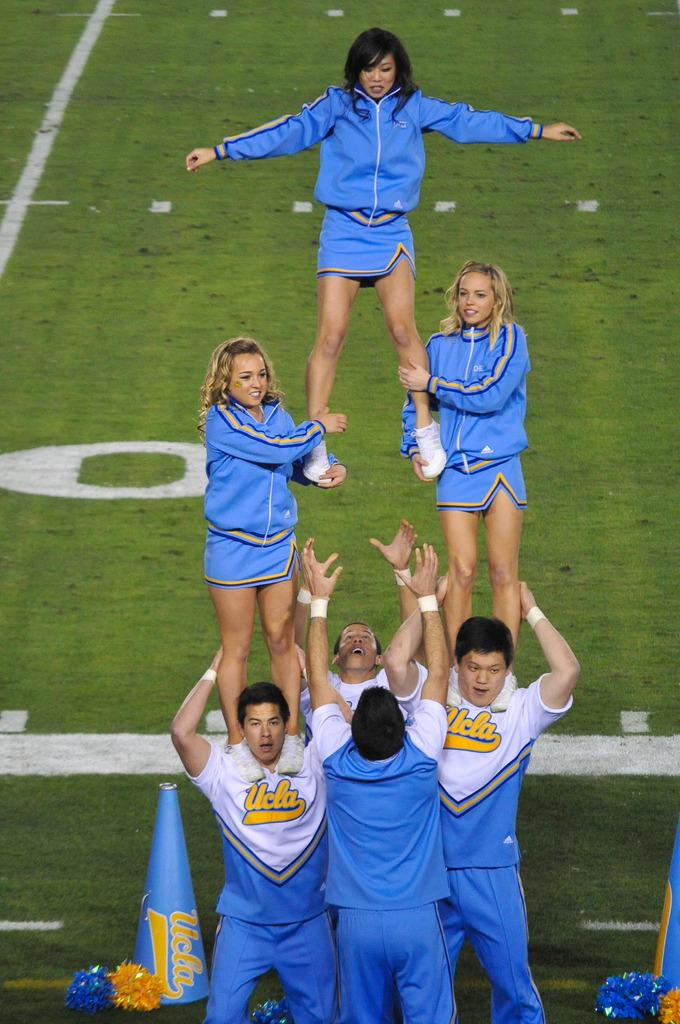<image>
Provide a brief description of the given image. A group of UCLA cheerleaders attempt to pull off a difficult routine. 